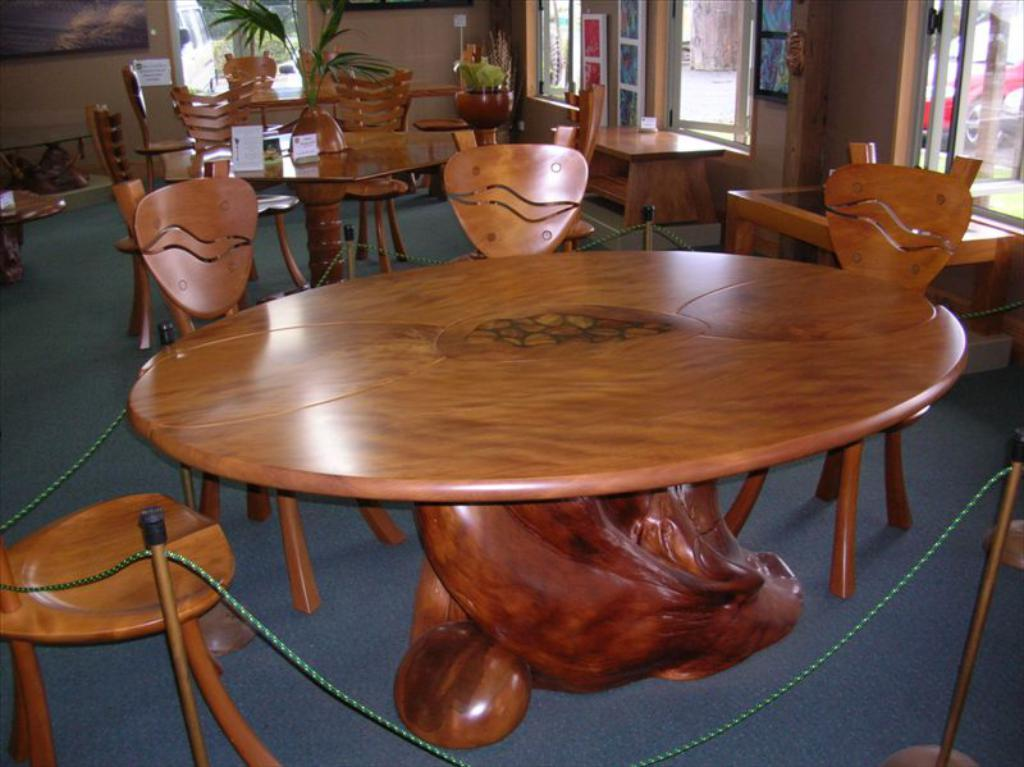What type of furniture is visible in the image? There are chairs and tables in the image. What architectural feature can be seen in the image? There are windows in the image. What type of vegetation is present in the image? There is a plant at the top of the image. What type of barrier is visible at the bottom of the image? There is a queue rope barrier at the bottom of the image. How many sisters are sitting on the chairs in the image? There is no mention of sisters in the image, and the number of people sitting on the chairs cannot be determined from the provided facts. What type of patch is sewn onto the tablecloth in the image? There is no patch visible on the tablecloth in the image. 